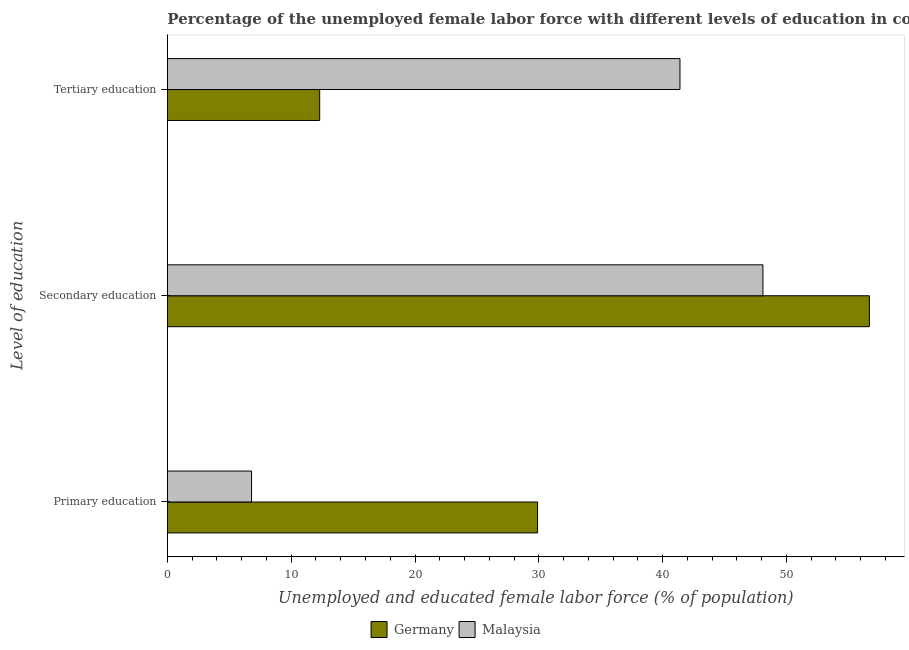How many different coloured bars are there?
Provide a short and direct response. 2. How many groups of bars are there?
Provide a short and direct response. 3. Are the number of bars per tick equal to the number of legend labels?
Keep it short and to the point. Yes. What is the label of the 2nd group of bars from the top?
Your response must be concise. Secondary education. What is the percentage of female labor force who received tertiary education in Germany?
Give a very brief answer. 12.3. Across all countries, what is the maximum percentage of female labor force who received primary education?
Offer a very short reply. 29.9. Across all countries, what is the minimum percentage of female labor force who received tertiary education?
Give a very brief answer. 12.3. In which country was the percentage of female labor force who received tertiary education maximum?
Keep it short and to the point. Malaysia. In which country was the percentage of female labor force who received secondary education minimum?
Your answer should be compact. Malaysia. What is the total percentage of female labor force who received tertiary education in the graph?
Your answer should be compact. 53.7. What is the difference between the percentage of female labor force who received secondary education in Germany and that in Malaysia?
Keep it short and to the point. 8.6. What is the difference between the percentage of female labor force who received secondary education in Germany and the percentage of female labor force who received tertiary education in Malaysia?
Provide a succinct answer. 15.3. What is the average percentage of female labor force who received secondary education per country?
Offer a very short reply. 52.4. What is the difference between the percentage of female labor force who received tertiary education and percentage of female labor force who received secondary education in Germany?
Ensure brevity in your answer.  -44.4. What is the ratio of the percentage of female labor force who received tertiary education in Germany to that in Malaysia?
Your answer should be compact. 0.3. What is the difference between the highest and the second highest percentage of female labor force who received tertiary education?
Offer a very short reply. 29.1. What is the difference between the highest and the lowest percentage of female labor force who received secondary education?
Offer a terse response. 8.6. What does the 1st bar from the top in Tertiary education represents?
Provide a short and direct response. Malaysia. What does the 2nd bar from the bottom in Secondary education represents?
Offer a terse response. Malaysia. How many bars are there?
Provide a short and direct response. 6. Are the values on the major ticks of X-axis written in scientific E-notation?
Provide a succinct answer. No. What is the title of the graph?
Keep it short and to the point. Percentage of the unemployed female labor force with different levels of education in countries. Does "Cayman Islands" appear as one of the legend labels in the graph?
Your answer should be very brief. No. What is the label or title of the X-axis?
Offer a very short reply. Unemployed and educated female labor force (% of population). What is the label or title of the Y-axis?
Ensure brevity in your answer.  Level of education. What is the Unemployed and educated female labor force (% of population) of Germany in Primary education?
Make the answer very short. 29.9. What is the Unemployed and educated female labor force (% of population) of Malaysia in Primary education?
Your answer should be very brief. 6.8. What is the Unemployed and educated female labor force (% of population) in Germany in Secondary education?
Your answer should be very brief. 56.7. What is the Unemployed and educated female labor force (% of population) of Malaysia in Secondary education?
Give a very brief answer. 48.1. What is the Unemployed and educated female labor force (% of population) of Germany in Tertiary education?
Ensure brevity in your answer.  12.3. What is the Unemployed and educated female labor force (% of population) in Malaysia in Tertiary education?
Give a very brief answer. 41.4. Across all Level of education, what is the maximum Unemployed and educated female labor force (% of population) of Germany?
Your answer should be very brief. 56.7. Across all Level of education, what is the maximum Unemployed and educated female labor force (% of population) of Malaysia?
Make the answer very short. 48.1. Across all Level of education, what is the minimum Unemployed and educated female labor force (% of population) in Germany?
Your answer should be very brief. 12.3. Across all Level of education, what is the minimum Unemployed and educated female labor force (% of population) in Malaysia?
Your response must be concise. 6.8. What is the total Unemployed and educated female labor force (% of population) in Germany in the graph?
Make the answer very short. 98.9. What is the total Unemployed and educated female labor force (% of population) in Malaysia in the graph?
Offer a very short reply. 96.3. What is the difference between the Unemployed and educated female labor force (% of population) in Germany in Primary education and that in Secondary education?
Provide a short and direct response. -26.8. What is the difference between the Unemployed and educated female labor force (% of population) in Malaysia in Primary education and that in Secondary education?
Keep it short and to the point. -41.3. What is the difference between the Unemployed and educated female labor force (% of population) in Malaysia in Primary education and that in Tertiary education?
Your answer should be compact. -34.6. What is the difference between the Unemployed and educated female labor force (% of population) of Germany in Secondary education and that in Tertiary education?
Keep it short and to the point. 44.4. What is the difference between the Unemployed and educated female labor force (% of population) of Malaysia in Secondary education and that in Tertiary education?
Keep it short and to the point. 6.7. What is the difference between the Unemployed and educated female labor force (% of population) in Germany in Primary education and the Unemployed and educated female labor force (% of population) in Malaysia in Secondary education?
Your answer should be compact. -18.2. What is the difference between the Unemployed and educated female labor force (% of population) of Germany in Secondary education and the Unemployed and educated female labor force (% of population) of Malaysia in Tertiary education?
Provide a succinct answer. 15.3. What is the average Unemployed and educated female labor force (% of population) of Germany per Level of education?
Offer a very short reply. 32.97. What is the average Unemployed and educated female labor force (% of population) in Malaysia per Level of education?
Provide a short and direct response. 32.1. What is the difference between the Unemployed and educated female labor force (% of population) of Germany and Unemployed and educated female labor force (% of population) of Malaysia in Primary education?
Keep it short and to the point. 23.1. What is the difference between the Unemployed and educated female labor force (% of population) of Germany and Unemployed and educated female labor force (% of population) of Malaysia in Secondary education?
Provide a short and direct response. 8.6. What is the difference between the Unemployed and educated female labor force (% of population) in Germany and Unemployed and educated female labor force (% of population) in Malaysia in Tertiary education?
Your answer should be compact. -29.1. What is the ratio of the Unemployed and educated female labor force (% of population) in Germany in Primary education to that in Secondary education?
Keep it short and to the point. 0.53. What is the ratio of the Unemployed and educated female labor force (% of population) of Malaysia in Primary education to that in Secondary education?
Offer a terse response. 0.14. What is the ratio of the Unemployed and educated female labor force (% of population) of Germany in Primary education to that in Tertiary education?
Offer a very short reply. 2.43. What is the ratio of the Unemployed and educated female labor force (% of population) in Malaysia in Primary education to that in Tertiary education?
Your answer should be compact. 0.16. What is the ratio of the Unemployed and educated female labor force (% of population) of Germany in Secondary education to that in Tertiary education?
Offer a very short reply. 4.61. What is the ratio of the Unemployed and educated female labor force (% of population) of Malaysia in Secondary education to that in Tertiary education?
Offer a terse response. 1.16. What is the difference between the highest and the second highest Unemployed and educated female labor force (% of population) of Germany?
Your answer should be very brief. 26.8. What is the difference between the highest and the lowest Unemployed and educated female labor force (% of population) of Germany?
Ensure brevity in your answer.  44.4. What is the difference between the highest and the lowest Unemployed and educated female labor force (% of population) in Malaysia?
Ensure brevity in your answer.  41.3. 